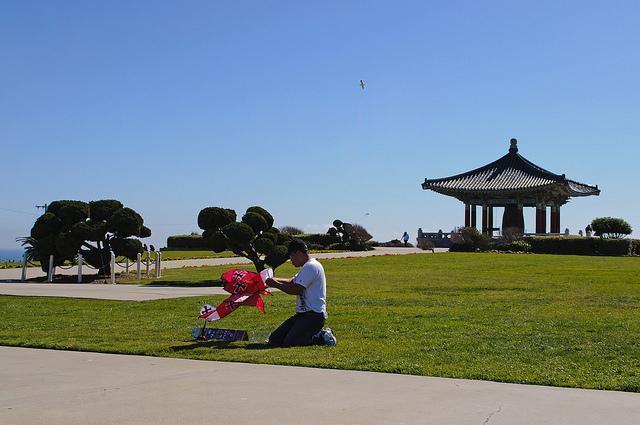What is the man kneeling going to do next?
Answer the question by selecting the correct answer among the 4 following choices.
Options: Play tennis, fly kite, go swimming, race cars. Fly kite. 